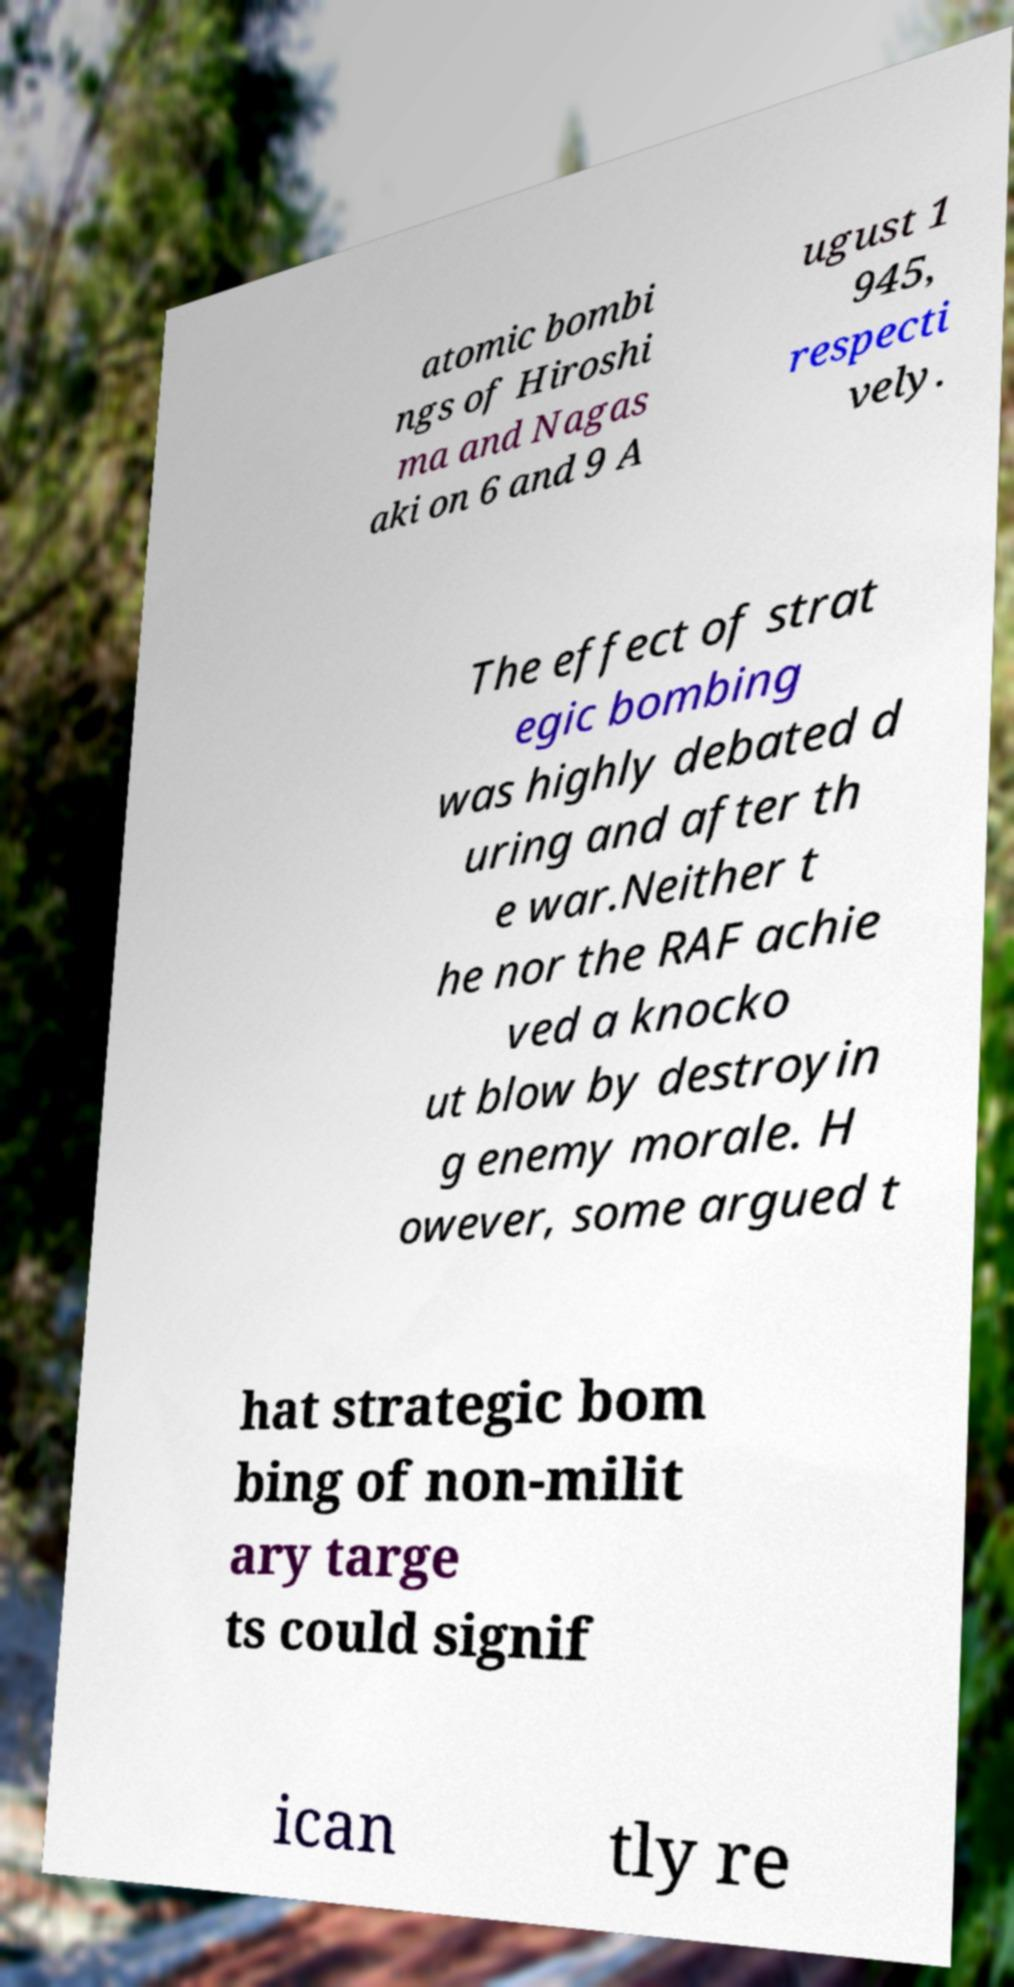There's text embedded in this image that I need extracted. Can you transcribe it verbatim? atomic bombi ngs of Hiroshi ma and Nagas aki on 6 and 9 A ugust 1 945, respecti vely. The effect of strat egic bombing was highly debated d uring and after th e war.Neither t he nor the RAF achie ved a knocko ut blow by destroyin g enemy morale. H owever, some argued t hat strategic bom bing of non-milit ary targe ts could signif ican tly re 